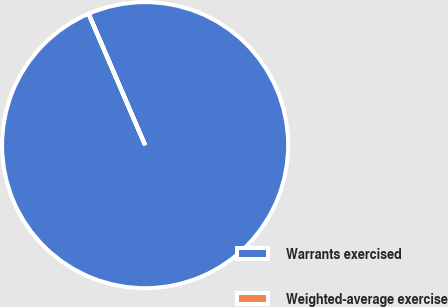Convert chart. <chart><loc_0><loc_0><loc_500><loc_500><pie_chart><fcel>Warrants exercised<fcel>Weighted-average exercise<nl><fcel>99.99%<fcel>0.01%<nl></chart> 